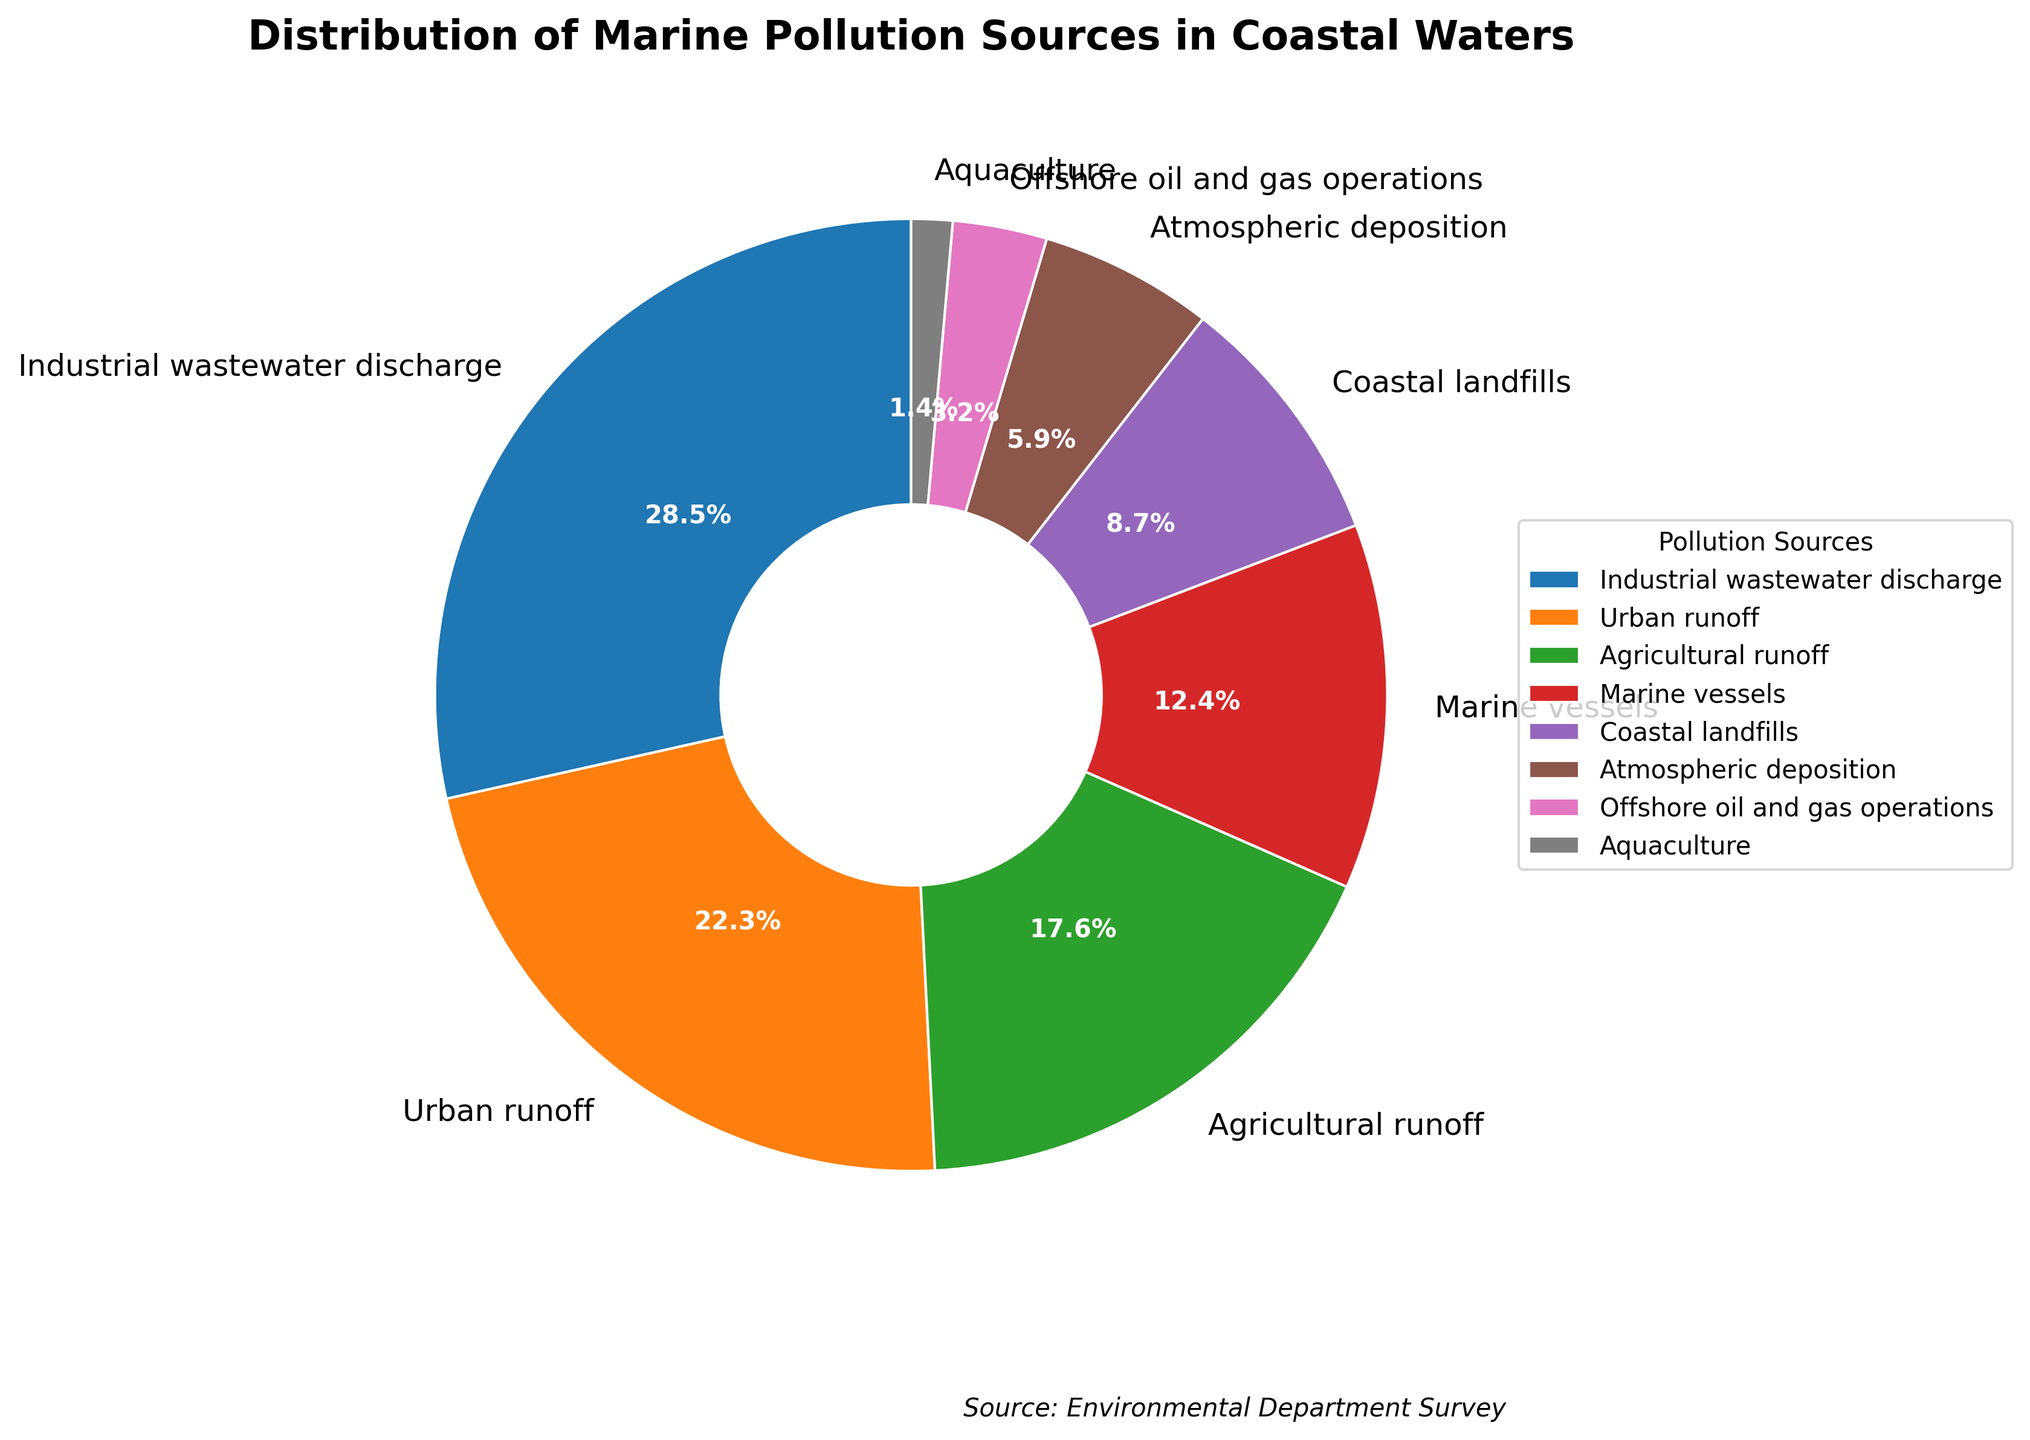What is the most significant source of marine pollution in the coastal waters? Look at the pie chart to determine which source occupies the largest segment. The segment labeled "Industrial wastewater discharge" represents 28.5%, the largest percentage among all sources depicted.
Answer: Industrial wastewater discharge What is the combined percentage of pollution from "urban runoff" and "agricultural runoff"? Sum the percentages for urban runoff and agricultural runoff: 22.3% + 17.6% = 39.9%.
Answer: 39.9% Which is the lesser contributor to marine pollution, "atmospheric deposition" or "offshore oil and gas operations"? Compare the segments for atmospheric deposition (5.9%) and offshore oil and gas operations (3.2%). Since 3.2% is smaller than 5.9%, offshore oil and gas operations is the lesser contributor.
Answer: Offshore oil and gas operations How does the percentage of pollution from "marine vessels" compare to "coastal landfills"? Compare the segments for marine vessels (12.4%) and coastal landfills (8.7%). Marine vessels contribute more since 12.4% is greater than 8.7%.
Answer: Marine vessels contribute more What is the total percentage of pollution caused by "coastal landfills," "atmospheric deposition," and "aquaculture"? Sum the percentages for coastal landfills (8.7%), atmospheric deposition (5.9%), and aquaculture (1.4%): 8.7% + 5.9% + 1.4% = 16%.
Answer: 16% By how much does the pollution percentage from "urban runoff" exceed that from "marine vessels"? Subtract the percentage of marine vessels (12.4%) from urban runoff (22.3%): 22.3% - 12.4% = 9.9%.
Answer: 9.9% If the goal is to address pollution sources contributing under 5%, which sources should be targeted? Identify the sources with percentages below 5%. This includes offshore oil and gas operations (3.2%) and aquaculture (1.4%).
Answer: Offshore oil and gas operations and aquaculture Which pollution source uses a color similar to "purple," and what is its percentage? The segment labeled "Coastal landfills" is colored similarly to purple and has a percentage of 8.7%.
Answer: Coastal landfills, 8.7% What is the second-largest source of pollution, and what percentage does it represent? Identify the segment that is next largest after the largest (industrial wastewater discharge, 28.5%). This is urban runoff with 22.3%.
Answer: Urban runoff, 22.3% What is the difference in pollution percentages between "industrial wastewater discharge" and "agricultural runoff"? Subtract the percentage of agricultural runoff (17.6%) from industrial wastewater discharge (28.5%): 28.5% - 17.6% = 10.9%.
Answer: 10.9% 